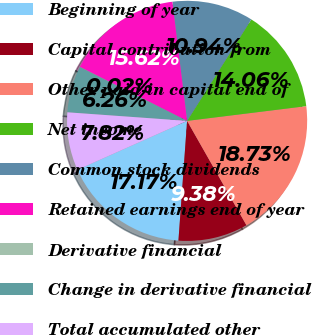Convert chart to OTSL. <chart><loc_0><loc_0><loc_500><loc_500><pie_chart><fcel>Beginning of year<fcel>Capital contribution from<fcel>Other paid-in capital end of<fcel>Net income<fcel>Common stock dividends<fcel>Retained earnings end of year<fcel>Derivative financial<fcel>Change in derivative financial<fcel>Total accumulated other<nl><fcel>17.17%<fcel>9.38%<fcel>18.73%<fcel>14.06%<fcel>10.94%<fcel>15.62%<fcel>0.02%<fcel>6.26%<fcel>7.82%<nl></chart> 